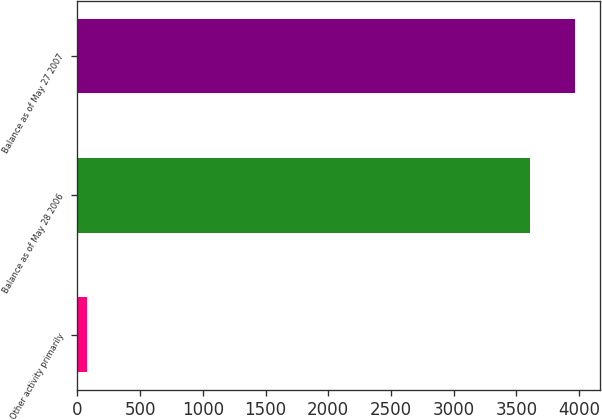<chart> <loc_0><loc_0><loc_500><loc_500><bar_chart><fcel>Other activity primarily<fcel>Balance as of May 28 2006<fcel>Balance as of May 27 2007<nl><fcel>75<fcel>3607.1<fcel>3969<nl></chart> 